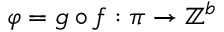Convert formula to latex. <formula><loc_0><loc_0><loc_500><loc_500>\varphi = g \circ f \colon \pi \to \mathbb { Z } ^ { b }</formula> 